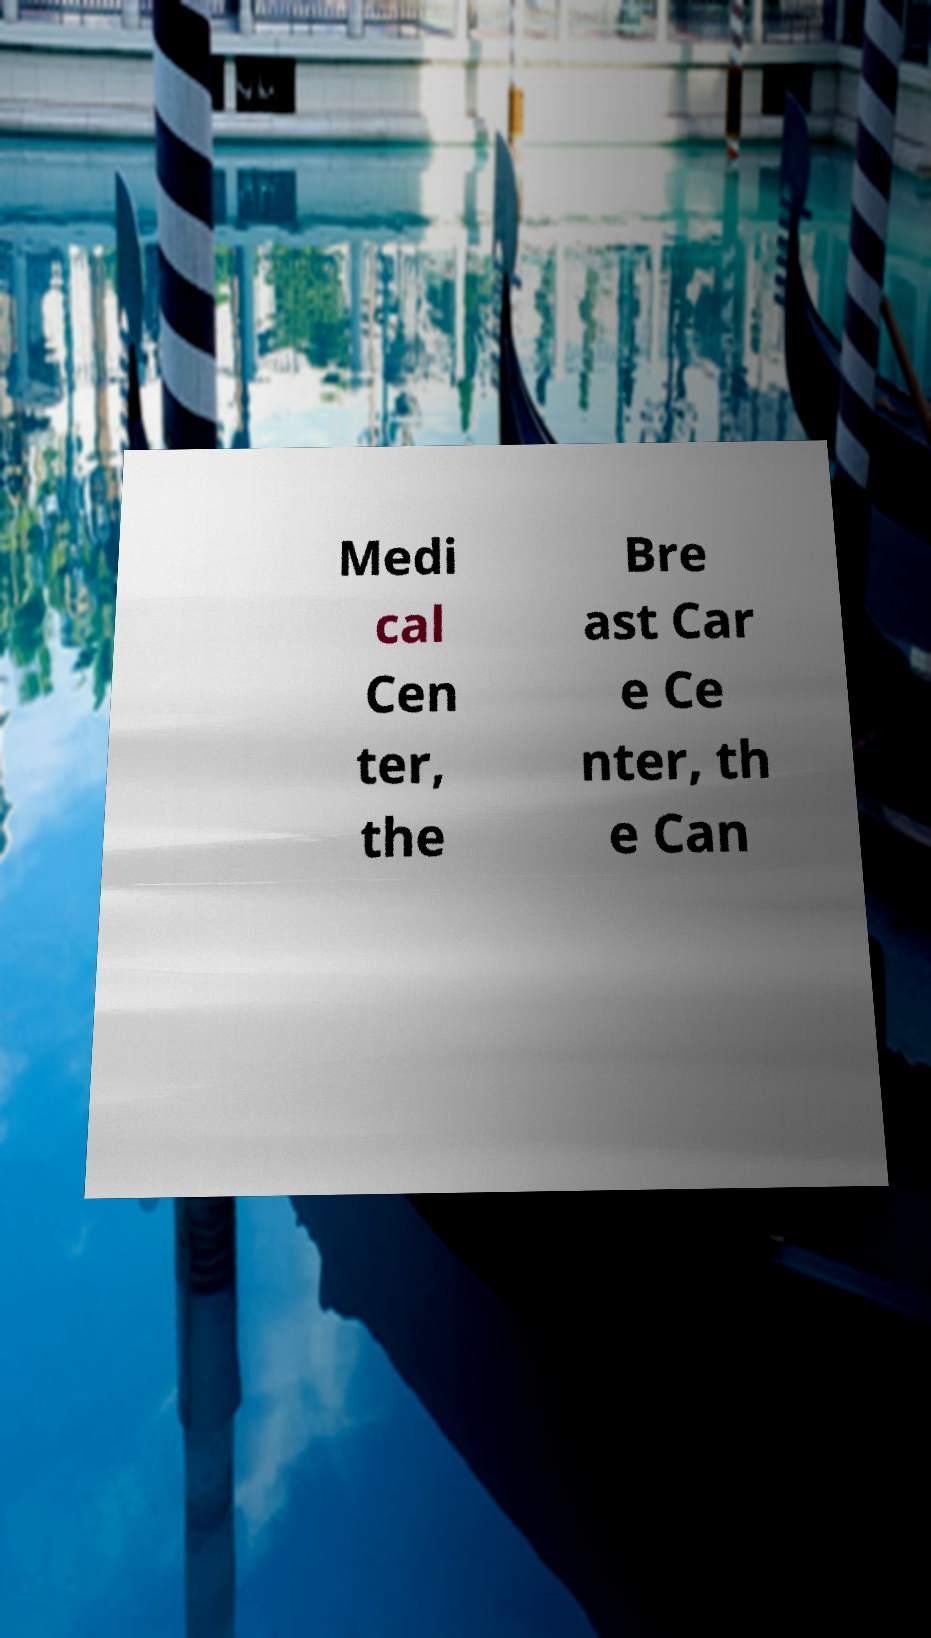I need the written content from this picture converted into text. Can you do that? Medi cal Cen ter, the Bre ast Car e Ce nter, th e Can 